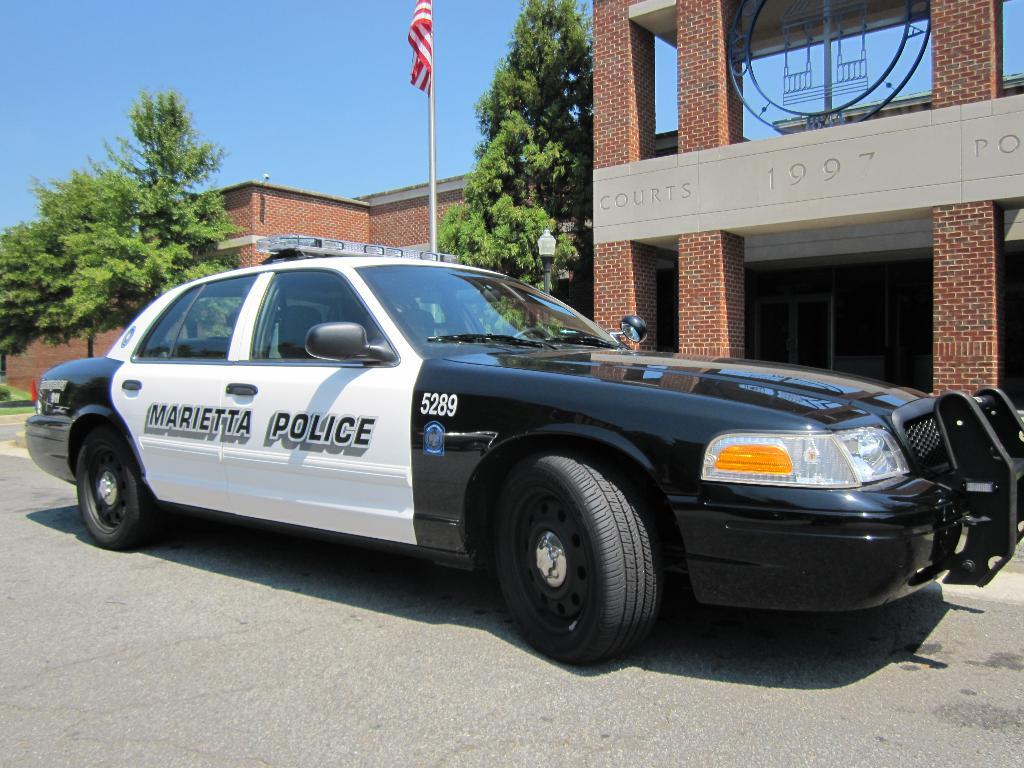What emergency vehicle is this?
Ensure brevity in your answer.  Police. 